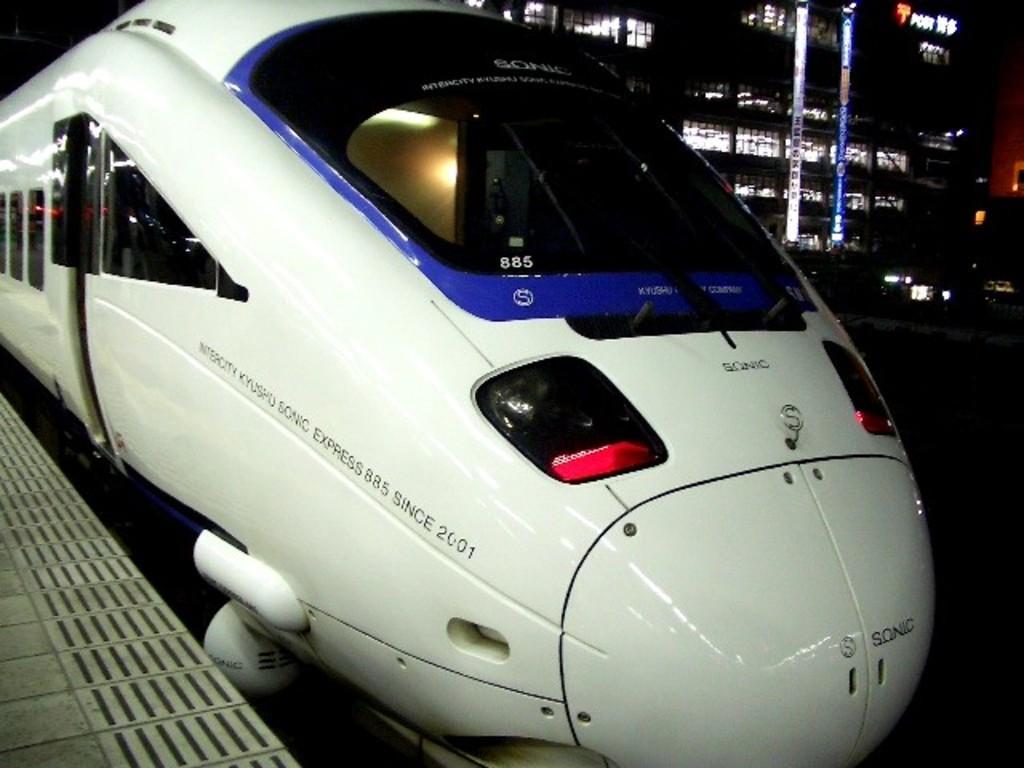Can you describe this image briefly? In the center of the image we can see a metro train with some text on it. On the left side of the image, there is a platform. In the background, we can see buildings, lights and a few other objects. 